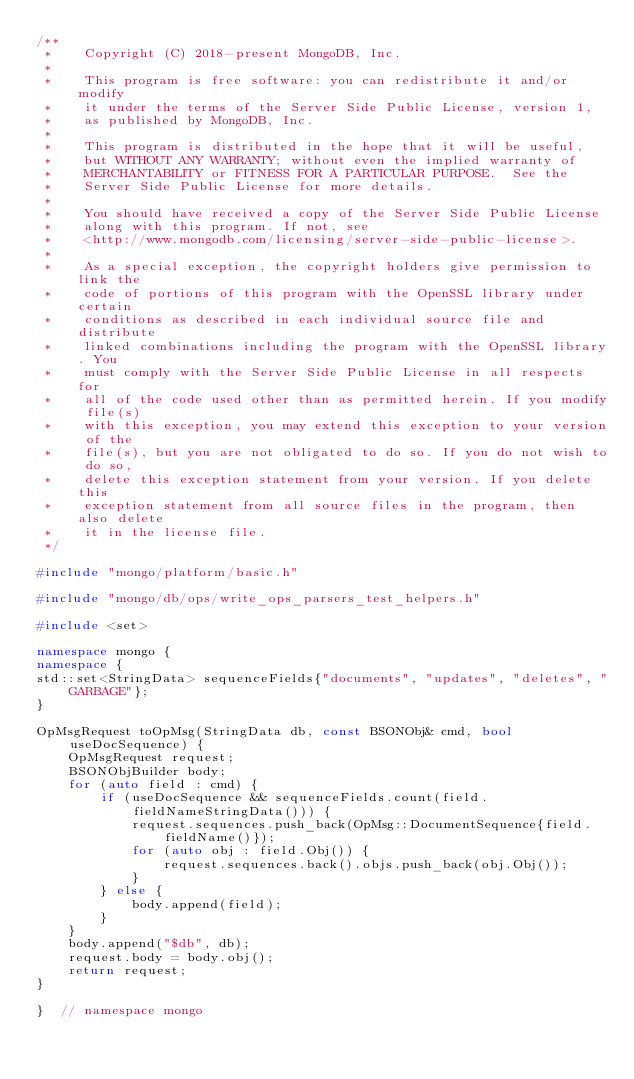Convert code to text. <code><loc_0><loc_0><loc_500><loc_500><_C++_>/**
 *    Copyright (C) 2018-present MongoDB, Inc.
 *
 *    This program is free software: you can redistribute it and/or modify
 *    it under the terms of the Server Side Public License, version 1,
 *    as published by MongoDB, Inc.
 *
 *    This program is distributed in the hope that it will be useful,
 *    but WITHOUT ANY WARRANTY; without even the implied warranty of
 *    MERCHANTABILITY or FITNESS FOR A PARTICULAR PURPOSE.  See the
 *    Server Side Public License for more details.
 *
 *    You should have received a copy of the Server Side Public License
 *    along with this program. If not, see
 *    <http://www.mongodb.com/licensing/server-side-public-license>.
 *
 *    As a special exception, the copyright holders give permission to link the
 *    code of portions of this program with the OpenSSL library under certain
 *    conditions as described in each individual source file and distribute
 *    linked combinations including the program with the OpenSSL library. You
 *    must comply with the Server Side Public License in all respects for
 *    all of the code used other than as permitted herein. If you modify file(s)
 *    with this exception, you may extend this exception to your version of the
 *    file(s), but you are not obligated to do so. If you do not wish to do so,
 *    delete this exception statement from your version. If you delete this
 *    exception statement from all source files in the program, then also delete
 *    it in the license file.
 */

#include "mongo/platform/basic.h"

#include "mongo/db/ops/write_ops_parsers_test_helpers.h"

#include <set>

namespace mongo {
namespace {
std::set<StringData> sequenceFields{"documents", "updates", "deletes", "GARBAGE"};
}

OpMsgRequest toOpMsg(StringData db, const BSONObj& cmd, bool useDocSequence) {
    OpMsgRequest request;
    BSONObjBuilder body;
    for (auto field : cmd) {
        if (useDocSequence && sequenceFields.count(field.fieldNameStringData())) {
            request.sequences.push_back(OpMsg::DocumentSequence{field.fieldName()});
            for (auto obj : field.Obj()) {
                request.sequences.back().objs.push_back(obj.Obj());
            }
        } else {
            body.append(field);
        }
    }
    body.append("$db", db);
    request.body = body.obj();
    return request;
}

}  // namespace mongo
</code> 